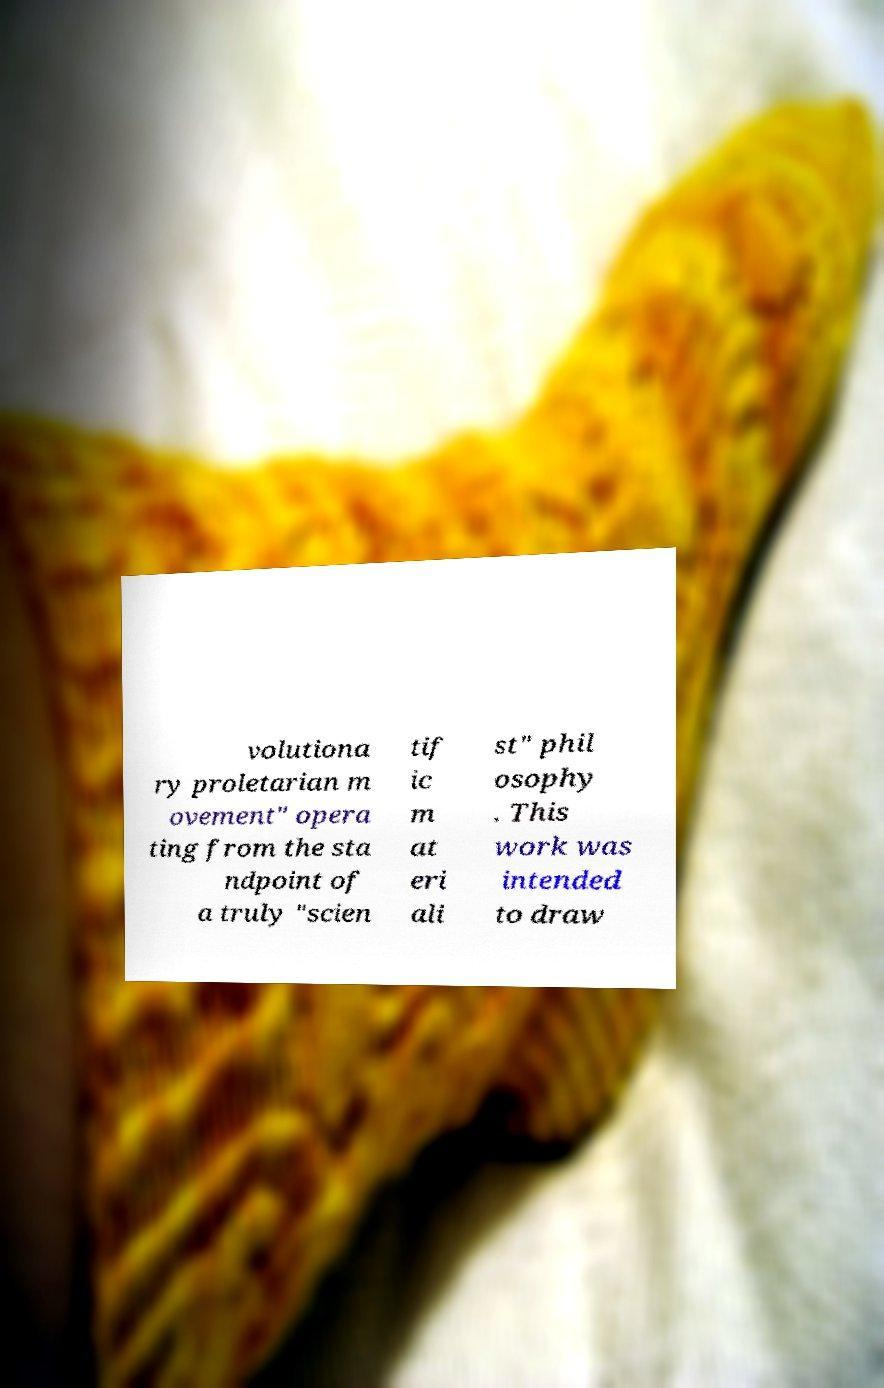Could you extract and type out the text from this image? volutiona ry proletarian m ovement" opera ting from the sta ndpoint of a truly "scien tif ic m at eri ali st" phil osophy . This work was intended to draw 